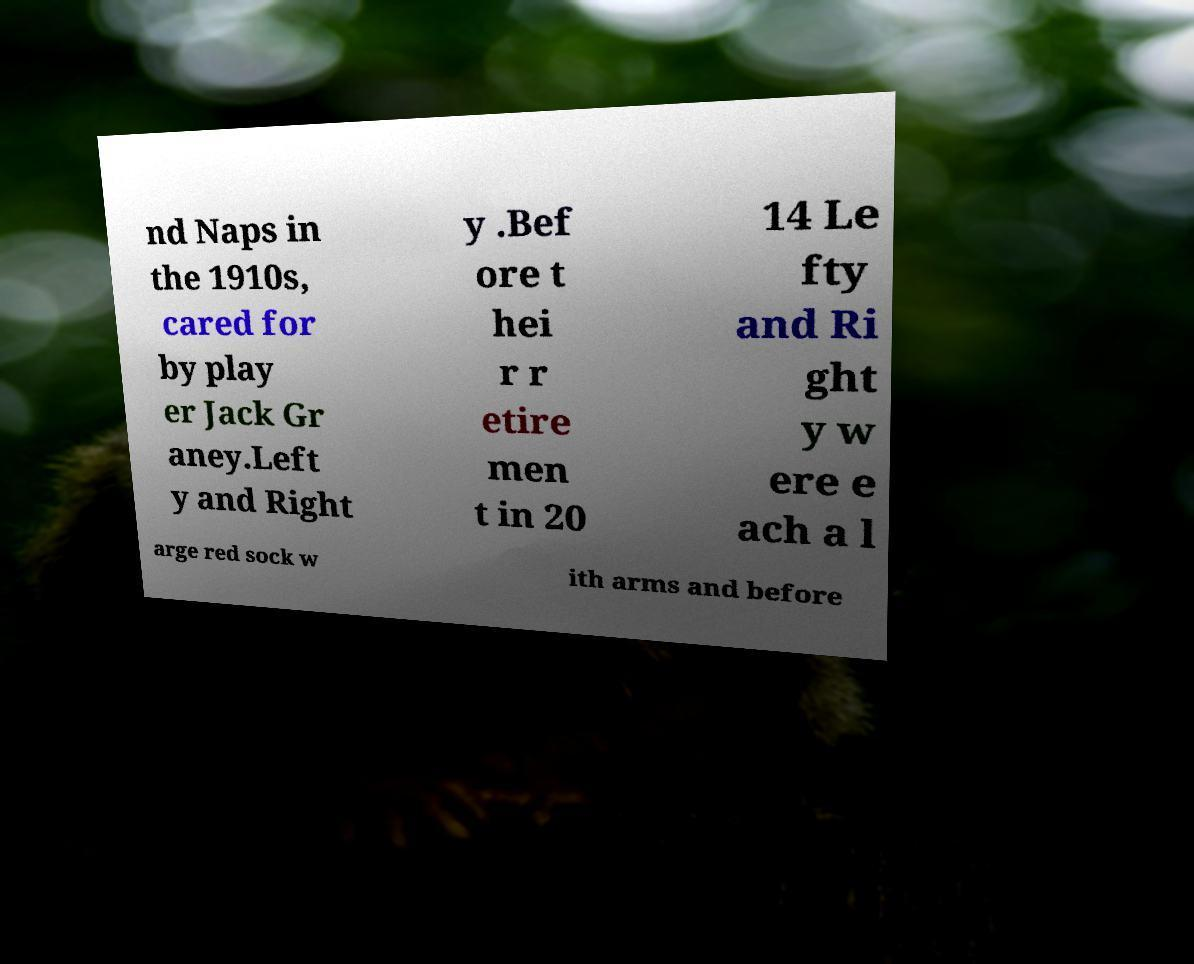Can you read and provide the text displayed in the image?This photo seems to have some interesting text. Can you extract and type it out for me? nd Naps in the 1910s, cared for by play er Jack Gr aney.Left y and Right y .Bef ore t hei r r etire men t in 20 14 Le fty and Ri ght y w ere e ach a l arge red sock w ith arms and before 